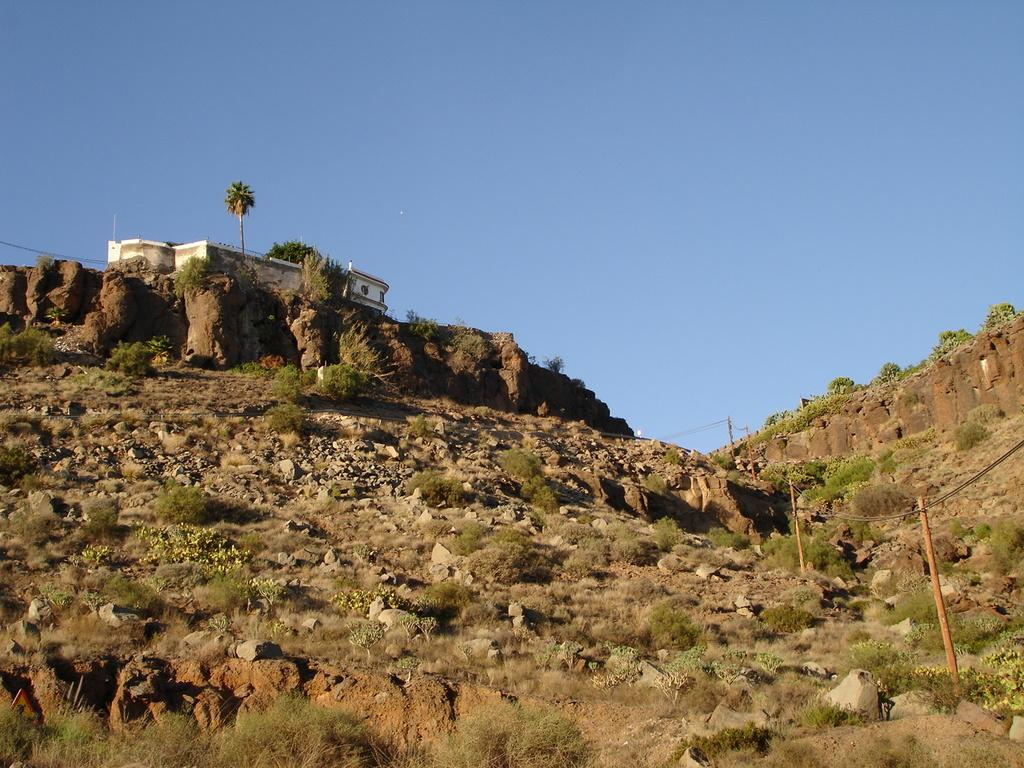What type of natural formation is visible in the image? There is a mountain in the image. What type of structure can be seen on the mountain? There is a building on a cliff in the image. What type of vegetation is present in the image? There are plants and trees in the image. What type of geological feature can be seen in the image? There are rocks in the image. What is the condition of the sky in the image? The sky is clear in the image. Can you tell me how many cows are grazing on the mountain in the image? There are no cows present in the image; it features a mountain, a building on a cliff, plants, trees, rocks, and a clear sky. What type of authority is depicted in the image? There is no authority figure present in the image. 